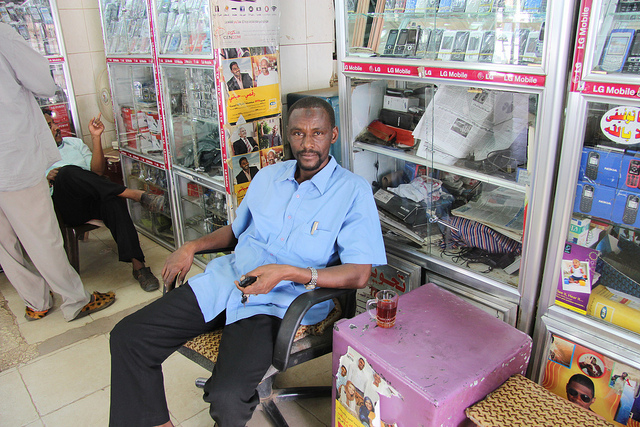Identify the text contained in this image. LG Mobile LG GO 